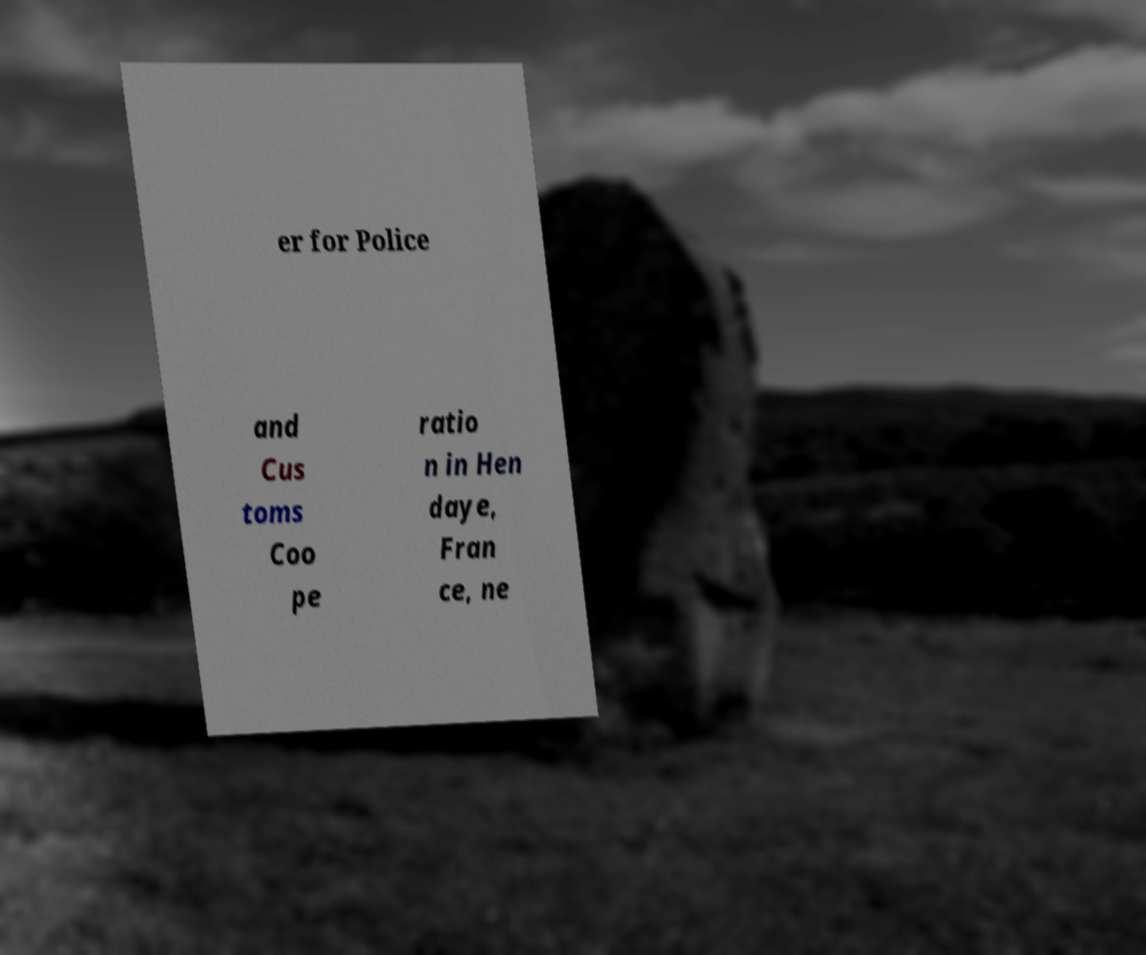Could you assist in decoding the text presented in this image and type it out clearly? er for Police and Cus toms Coo pe ratio n in Hen daye, Fran ce, ne 